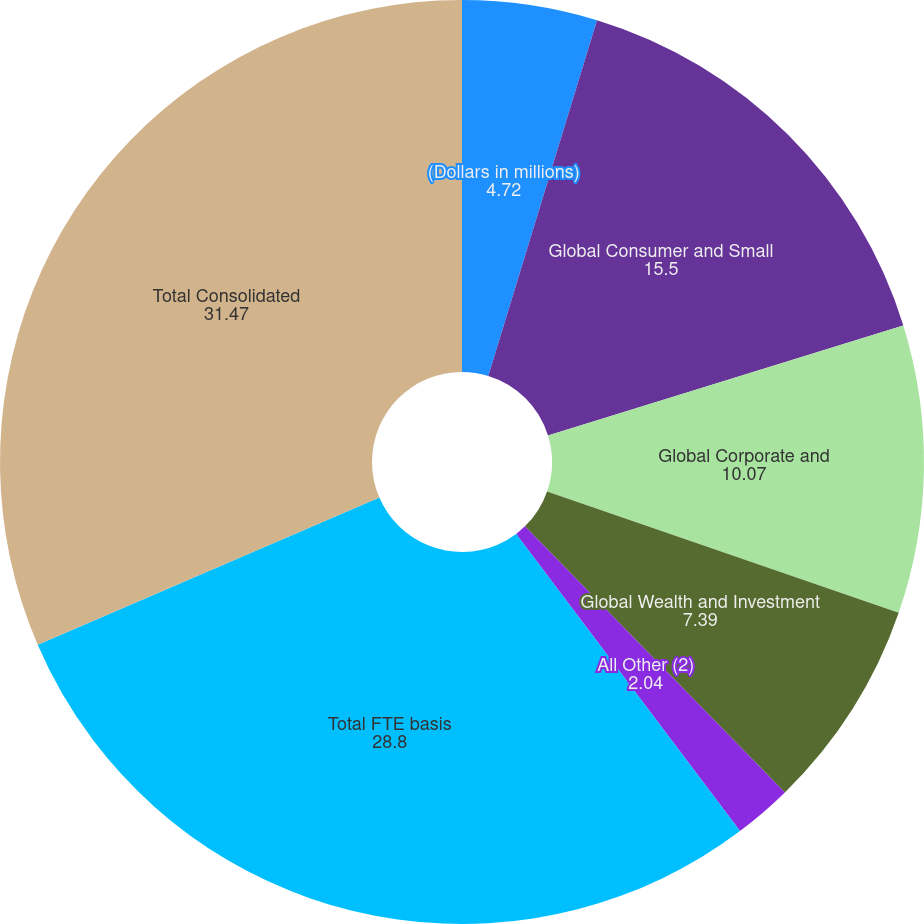Convert chart. <chart><loc_0><loc_0><loc_500><loc_500><pie_chart><fcel>(Dollars in millions)<fcel>Global Consumer and Small<fcel>Global Corporate and<fcel>Global Wealth and Investment<fcel>All Other (2)<fcel>Total FTE basis<fcel>Total Consolidated<nl><fcel>4.72%<fcel>15.5%<fcel>10.07%<fcel>7.39%<fcel>2.04%<fcel>28.8%<fcel>31.47%<nl></chart> 